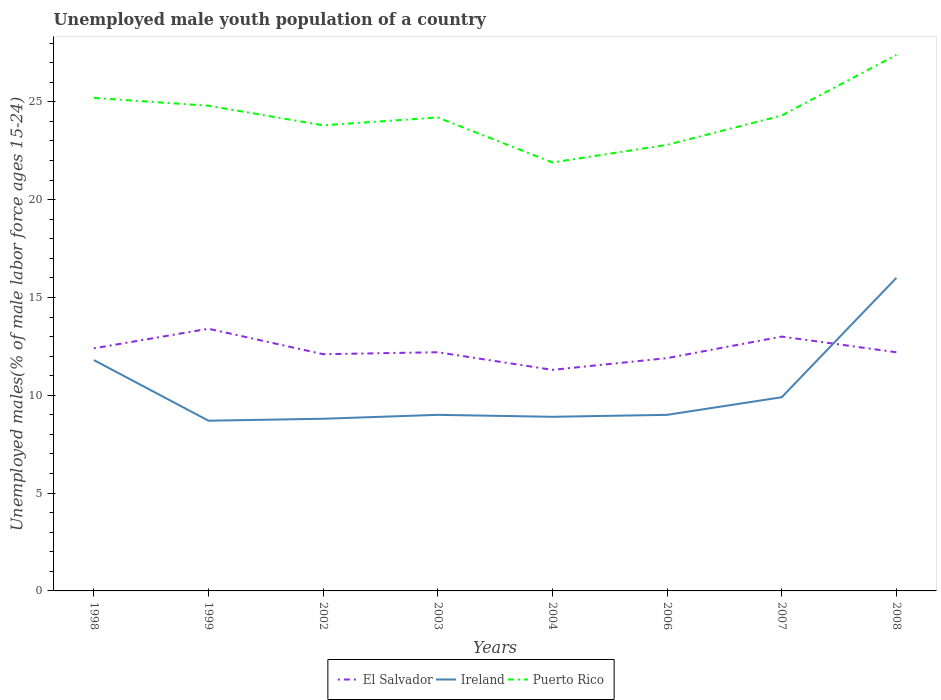How many different coloured lines are there?
Keep it short and to the point. 3. Does the line corresponding to El Salvador intersect with the line corresponding to Ireland?
Provide a succinct answer. Yes. Is the number of lines equal to the number of legend labels?
Ensure brevity in your answer.  Yes. Across all years, what is the maximum percentage of unemployed male youth population in El Salvador?
Provide a succinct answer. 11.3. What is the total percentage of unemployed male youth population in El Salvador in the graph?
Ensure brevity in your answer.  0.8. What is the difference between the highest and the second highest percentage of unemployed male youth population in El Salvador?
Give a very brief answer. 2.1. What is the difference between the highest and the lowest percentage of unemployed male youth population in Puerto Rico?
Your response must be concise. 3. How many years are there in the graph?
Ensure brevity in your answer.  8. Are the values on the major ticks of Y-axis written in scientific E-notation?
Offer a terse response. No. How many legend labels are there?
Offer a terse response. 3. How are the legend labels stacked?
Ensure brevity in your answer.  Horizontal. What is the title of the graph?
Your response must be concise. Unemployed male youth population of a country. What is the label or title of the X-axis?
Keep it short and to the point. Years. What is the label or title of the Y-axis?
Offer a terse response. Unemployed males(% of male labor force ages 15-24). What is the Unemployed males(% of male labor force ages 15-24) in El Salvador in 1998?
Your answer should be compact. 12.4. What is the Unemployed males(% of male labor force ages 15-24) of Ireland in 1998?
Offer a terse response. 11.8. What is the Unemployed males(% of male labor force ages 15-24) in Puerto Rico in 1998?
Offer a very short reply. 25.2. What is the Unemployed males(% of male labor force ages 15-24) in El Salvador in 1999?
Your answer should be compact. 13.4. What is the Unemployed males(% of male labor force ages 15-24) of Ireland in 1999?
Give a very brief answer. 8.7. What is the Unemployed males(% of male labor force ages 15-24) of Puerto Rico in 1999?
Your response must be concise. 24.8. What is the Unemployed males(% of male labor force ages 15-24) of El Salvador in 2002?
Keep it short and to the point. 12.1. What is the Unemployed males(% of male labor force ages 15-24) in Ireland in 2002?
Keep it short and to the point. 8.8. What is the Unemployed males(% of male labor force ages 15-24) in Puerto Rico in 2002?
Your answer should be very brief. 23.8. What is the Unemployed males(% of male labor force ages 15-24) in El Salvador in 2003?
Keep it short and to the point. 12.2. What is the Unemployed males(% of male labor force ages 15-24) in Ireland in 2003?
Keep it short and to the point. 9. What is the Unemployed males(% of male labor force ages 15-24) in Puerto Rico in 2003?
Keep it short and to the point. 24.2. What is the Unemployed males(% of male labor force ages 15-24) in El Salvador in 2004?
Offer a very short reply. 11.3. What is the Unemployed males(% of male labor force ages 15-24) in Ireland in 2004?
Offer a very short reply. 8.9. What is the Unemployed males(% of male labor force ages 15-24) in Puerto Rico in 2004?
Your response must be concise. 21.9. What is the Unemployed males(% of male labor force ages 15-24) of El Salvador in 2006?
Your answer should be compact. 11.9. What is the Unemployed males(% of male labor force ages 15-24) in Ireland in 2006?
Provide a succinct answer. 9. What is the Unemployed males(% of male labor force ages 15-24) in Puerto Rico in 2006?
Your answer should be compact. 22.8. What is the Unemployed males(% of male labor force ages 15-24) in Ireland in 2007?
Offer a very short reply. 9.9. What is the Unemployed males(% of male labor force ages 15-24) in Puerto Rico in 2007?
Your response must be concise. 24.3. What is the Unemployed males(% of male labor force ages 15-24) in El Salvador in 2008?
Keep it short and to the point. 12.2. What is the Unemployed males(% of male labor force ages 15-24) of Ireland in 2008?
Offer a terse response. 16. What is the Unemployed males(% of male labor force ages 15-24) of Puerto Rico in 2008?
Provide a short and direct response. 27.4. Across all years, what is the maximum Unemployed males(% of male labor force ages 15-24) in El Salvador?
Ensure brevity in your answer.  13.4. Across all years, what is the maximum Unemployed males(% of male labor force ages 15-24) of Ireland?
Give a very brief answer. 16. Across all years, what is the maximum Unemployed males(% of male labor force ages 15-24) of Puerto Rico?
Your answer should be compact. 27.4. Across all years, what is the minimum Unemployed males(% of male labor force ages 15-24) of El Salvador?
Offer a terse response. 11.3. Across all years, what is the minimum Unemployed males(% of male labor force ages 15-24) of Ireland?
Your response must be concise. 8.7. Across all years, what is the minimum Unemployed males(% of male labor force ages 15-24) of Puerto Rico?
Provide a short and direct response. 21.9. What is the total Unemployed males(% of male labor force ages 15-24) in El Salvador in the graph?
Keep it short and to the point. 98.5. What is the total Unemployed males(% of male labor force ages 15-24) in Ireland in the graph?
Offer a terse response. 82.1. What is the total Unemployed males(% of male labor force ages 15-24) of Puerto Rico in the graph?
Your answer should be compact. 194.4. What is the difference between the Unemployed males(% of male labor force ages 15-24) in Ireland in 1998 and that in 1999?
Offer a very short reply. 3.1. What is the difference between the Unemployed males(% of male labor force ages 15-24) in El Salvador in 1998 and that in 2002?
Your response must be concise. 0.3. What is the difference between the Unemployed males(% of male labor force ages 15-24) of Ireland in 1998 and that in 2002?
Make the answer very short. 3. What is the difference between the Unemployed males(% of male labor force ages 15-24) of El Salvador in 1998 and that in 2003?
Your answer should be compact. 0.2. What is the difference between the Unemployed males(% of male labor force ages 15-24) of Puerto Rico in 1998 and that in 2003?
Ensure brevity in your answer.  1. What is the difference between the Unemployed males(% of male labor force ages 15-24) in Puerto Rico in 1998 and that in 2006?
Provide a succinct answer. 2.4. What is the difference between the Unemployed males(% of male labor force ages 15-24) of Puerto Rico in 1998 and that in 2007?
Your answer should be very brief. 0.9. What is the difference between the Unemployed males(% of male labor force ages 15-24) in El Salvador in 1998 and that in 2008?
Ensure brevity in your answer.  0.2. What is the difference between the Unemployed males(% of male labor force ages 15-24) of Puerto Rico in 1999 and that in 2002?
Make the answer very short. 1. What is the difference between the Unemployed males(% of male labor force ages 15-24) in Puerto Rico in 1999 and that in 2003?
Make the answer very short. 0.6. What is the difference between the Unemployed males(% of male labor force ages 15-24) of Ireland in 1999 and that in 2004?
Your answer should be compact. -0.2. What is the difference between the Unemployed males(% of male labor force ages 15-24) of Puerto Rico in 1999 and that in 2004?
Ensure brevity in your answer.  2.9. What is the difference between the Unemployed males(% of male labor force ages 15-24) in Puerto Rico in 1999 and that in 2006?
Offer a terse response. 2. What is the difference between the Unemployed males(% of male labor force ages 15-24) of Ireland in 1999 and that in 2007?
Make the answer very short. -1.2. What is the difference between the Unemployed males(% of male labor force ages 15-24) of Puerto Rico in 1999 and that in 2007?
Keep it short and to the point. 0.5. What is the difference between the Unemployed males(% of male labor force ages 15-24) in El Salvador in 1999 and that in 2008?
Make the answer very short. 1.2. What is the difference between the Unemployed males(% of male labor force ages 15-24) of Ireland in 2002 and that in 2003?
Make the answer very short. -0.2. What is the difference between the Unemployed males(% of male labor force ages 15-24) in Puerto Rico in 2002 and that in 2003?
Offer a very short reply. -0.4. What is the difference between the Unemployed males(% of male labor force ages 15-24) of Ireland in 2002 and that in 2004?
Give a very brief answer. -0.1. What is the difference between the Unemployed males(% of male labor force ages 15-24) of El Salvador in 2002 and that in 2006?
Provide a succinct answer. 0.2. What is the difference between the Unemployed males(% of male labor force ages 15-24) in Ireland in 2002 and that in 2006?
Provide a succinct answer. -0.2. What is the difference between the Unemployed males(% of male labor force ages 15-24) in El Salvador in 2002 and that in 2007?
Ensure brevity in your answer.  -0.9. What is the difference between the Unemployed males(% of male labor force ages 15-24) of Puerto Rico in 2002 and that in 2008?
Offer a terse response. -3.6. What is the difference between the Unemployed males(% of male labor force ages 15-24) in El Salvador in 2003 and that in 2004?
Make the answer very short. 0.9. What is the difference between the Unemployed males(% of male labor force ages 15-24) in Ireland in 2003 and that in 2004?
Provide a succinct answer. 0.1. What is the difference between the Unemployed males(% of male labor force ages 15-24) of Puerto Rico in 2003 and that in 2006?
Offer a terse response. 1.4. What is the difference between the Unemployed males(% of male labor force ages 15-24) of Ireland in 2003 and that in 2008?
Your answer should be very brief. -7. What is the difference between the Unemployed males(% of male labor force ages 15-24) of Puerto Rico in 2003 and that in 2008?
Keep it short and to the point. -3.2. What is the difference between the Unemployed males(% of male labor force ages 15-24) in Ireland in 2004 and that in 2006?
Ensure brevity in your answer.  -0.1. What is the difference between the Unemployed males(% of male labor force ages 15-24) of El Salvador in 2004 and that in 2008?
Ensure brevity in your answer.  -0.9. What is the difference between the Unemployed males(% of male labor force ages 15-24) of Ireland in 2004 and that in 2008?
Provide a succinct answer. -7.1. What is the difference between the Unemployed males(% of male labor force ages 15-24) in Puerto Rico in 2004 and that in 2008?
Keep it short and to the point. -5.5. What is the difference between the Unemployed males(% of male labor force ages 15-24) in Ireland in 2006 and that in 2008?
Offer a terse response. -7. What is the difference between the Unemployed males(% of male labor force ages 15-24) in Puerto Rico in 2006 and that in 2008?
Your answer should be very brief. -4.6. What is the difference between the Unemployed males(% of male labor force ages 15-24) in El Salvador in 2007 and that in 2008?
Your response must be concise. 0.8. What is the difference between the Unemployed males(% of male labor force ages 15-24) of Puerto Rico in 2007 and that in 2008?
Your answer should be very brief. -3.1. What is the difference between the Unemployed males(% of male labor force ages 15-24) of El Salvador in 1998 and the Unemployed males(% of male labor force ages 15-24) of Puerto Rico in 1999?
Provide a short and direct response. -12.4. What is the difference between the Unemployed males(% of male labor force ages 15-24) in Ireland in 1998 and the Unemployed males(% of male labor force ages 15-24) in Puerto Rico in 2002?
Make the answer very short. -12. What is the difference between the Unemployed males(% of male labor force ages 15-24) in El Salvador in 1998 and the Unemployed males(% of male labor force ages 15-24) in Ireland in 2003?
Make the answer very short. 3.4. What is the difference between the Unemployed males(% of male labor force ages 15-24) of El Salvador in 1998 and the Unemployed males(% of male labor force ages 15-24) of Puerto Rico in 2003?
Your answer should be very brief. -11.8. What is the difference between the Unemployed males(% of male labor force ages 15-24) of Ireland in 1998 and the Unemployed males(% of male labor force ages 15-24) of Puerto Rico in 2003?
Keep it short and to the point. -12.4. What is the difference between the Unemployed males(% of male labor force ages 15-24) of El Salvador in 1998 and the Unemployed males(% of male labor force ages 15-24) of Ireland in 2006?
Your response must be concise. 3.4. What is the difference between the Unemployed males(% of male labor force ages 15-24) of Ireland in 1998 and the Unemployed males(% of male labor force ages 15-24) of Puerto Rico in 2008?
Provide a short and direct response. -15.6. What is the difference between the Unemployed males(% of male labor force ages 15-24) in El Salvador in 1999 and the Unemployed males(% of male labor force ages 15-24) in Puerto Rico in 2002?
Your response must be concise. -10.4. What is the difference between the Unemployed males(% of male labor force ages 15-24) in Ireland in 1999 and the Unemployed males(% of male labor force ages 15-24) in Puerto Rico in 2002?
Ensure brevity in your answer.  -15.1. What is the difference between the Unemployed males(% of male labor force ages 15-24) in El Salvador in 1999 and the Unemployed males(% of male labor force ages 15-24) in Ireland in 2003?
Your answer should be compact. 4.4. What is the difference between the Unemployed males(% of male labor force ages 15-24) of El Salvador in 1999 and the Unemployed males(% of male labor force ages 15-24) of Puerto Rico in 2003?
Your response must be concise. -10.8. What is the difference between the Unemployed males(% of male labor force ages 15-24) in Ireland in 1999 and the Unemployed males(% of male labor force ages 15-24) in Puerto Rico in 2003?
Offer a very short reply. -15.5. What is the difference between the Unemployed males(% of male labor force ages 15-24) of El Salvador in 1999 and the Unemployed males(% of male labor force ages 15-24) of Puerto Rico in 2004?
Provide a short and direct response. -8.5. What is the difference between the Unemployed males(% of male labor force ages 15-24) in El Salvador in 1999 and the Unemployed males(% of male labor force ages 15-24) in Ireland in 2006?
Ensure brevity in your answer.  4.4. What is the difference between the Unemployed males(% of male labor force ages 15-24) of Ireland in 1999 and the Unemployed males(% of male labor force ages 15-24) of Puerto Rico in 2006?
Provide a succinct answer. -14.1. What is the difference between the Unemployed males(% of male labor force ages 15-24) of Ireland in 1999 and the Unemployed males(% of male labor force ages 15-24) of Puerto Rico in 2007?
Provide a short and direct response. -15.6. What is the difference between the Unemployed males(% of male labor force ages 15-24) in Ireland in 1999 and the Unemployed males(% of male labor force ages 15-24) in Puerto Rico in 2008?
Offer a terse response. -18.7. What is the difference between the Unemployed males(% of male labor force ages 15-24) in El Salvador in 2002 and the Unemployed males(% of male labor force ages 15-24) in Ireland in 2003?
Your response must be concise. 3.1. What is the difference between the Unemployed males(% of male labor force ages 15-24) of Ireland in 2002 and the Unemployed males(% of male labor force ages 15-24) of Puerto Rico in 2003?
Ensure brevity in your answer.  -15.4. What is the difference between the Unemployed males(% of male labor force ages 15-24) of Ireland in 2002 and the Unemployed males(% of male labor force ages 15-24) of Puerto Rico in 2004?
Offer a very short reply. -13.1. What is the difference between the Unemployed males(% of male labor force ages 15-24) of El Salvador in 2002 and the Unemployed males(% of male labor force ages 15-24) of Ireland in 2006?
Make the answer very short. 3.1. What is the difference between the Unemployed males(% of male labor force ages 15-24) of El Salvador in 2002 and the Unemployed males(% of male labor force ages 15-24) of Puerto Rico in 2006?
Your answer should be very brief. -10.7. What is the difference between the Unemployed males(% of male labor force ages 15-24) of Ireland in 2002 and the Unemployed males(% of male labor force ages 15-24) of Puerto Rico in 2007?
Offer a terse response. -15.5. What is the difference between the Unemployed males(% of male labor force ages 15-24) of El Salvador in 2002 and the Unemployed males(% of male labor force ages 15-24) of Ireland in 2008?
Provide a short and direct response. -3.9. What is the difference between the Unemployed males(% of male labor force ages 15-24) of El Salvador in 2002 and the Unemployed males(% of male labor force ages 15-24) of Puerto Rico in 2008?
Offer a terse response. -15.3. What is the difference between the Unemployed males(% of male labor force ages 15-24) of Ireland in 2002 and the Unemployed males(% of male labor force ages 15-24) of Puerto Rico in 2008?
Your answer should be compact. -18.6. What is the difference between the Unemployed males(% of male labor force ages 15-24) in El Salvador in 2003 and the Unemployed males(% of male labor force ages 15-24) in Puerto Rico in 2004?
Your response must be concise. -9.7. What is the difference between the Unemployed males(% of male labor force ages 15-24) of El Salvador in 2003 and the Unemployed males(% of male labor force ages 15-24) of Ireland in 2006?
Provide a short and direct response. 3.2. What is the difference between the Unemployed males(% of male labor force ages 15-24) in Ireland in 2003 and the Unemployed males(% of male labor force ages 15-24) in Puerto Rico in 2006?
Provide a succinct answer. -13.8. What is the difference between the Unemployed males(% of male labor force ages 15-24) of El Salvador in 2003 and the Unemployed males(% of male labor force ages 15-24) of Ireland in 2007?
Ensure brevity in your answer.  2.3. What is the difference between the Unemployed males(% of male labor force ages 15-24) of Ireland in 2003 and the Unemployed males(% of male labor force ages 15-24) of Puerto Rico in 2007?
Your answer should be compact. -15.3. What is the difference between the Unemployed males(% of male labor force ages 15-24) of El Salvador in 2003 and the Unemployed males(% of male labor force ages 15-24) of Ireland in 2008?
Provide a succinct answer. -3.8. What is the difference between the Unemployed males(% of male labor force ages 15-24) of El Salvador in 2003 and the Unemployed males(% of male labor force ages 15-24) of Puerto Rico in 2008?
Your response must be concise. -15.2. What is the difference between the Unemployed males(% of male labor force ages 15-24) of Ireland in 2003 and the Unemployed males(% of male labor force ages 15-24) of Puerto Rico in 2008?
Offer a terse response. -18.4. What is the difference between the Unemployed males(% of male labor force ages 15-24) in El Salvador in 2004 and the Unemployed males(% of male labor force ages 15-24) in Ireland in 2006?
Offer a very short reply. 2.3. What is the difference between the Unemployed males(% of male labor force ages 15-24) of El Salvador in 2004 and the Unemployed males(% of male labor force ages 15-24) of Puerto Rico in 2006?
Your answer should be very brief. -11.5. What is the difference between the Unemployed males(% of male labor force ages 15-24) in Ireland in 2004 and the Unemployed males(% of male labor force ages 15-24) in Puerto Rico in 2006?
Offer a very short reply. -13.9. What is the difference between the Unemployed males(% of male labor force ages 15-24) in Ireland in 2004 and the Unemployed males(% of male labor force ages 15-24) in Puerto Rico in 2007?
Make the answer very short. -15.4. What is the difference between the Unemployed males(% of male labor force ages 15-24) in El Salvador in 2004 and the Unemployed males(% of male labor force ages 15-24) in Ireland in 2008?
Give a very brief answer. -4.7. What is the difference between the Unemployed males(% of male labor force ages 15-24) in El Salvador in 2004 and the Unemployed males(% of male labor force ages 15-24) in Puerto Rico in 2008?
Offer a very short reply. -16.1. What is the difference between the Unemployed males(% of male labor force ages 15-24) in Ireland in 2004 and the Unemployed males(% of male labor force ages 15-24) in Puerto Rico in 2008?
Offer a terse response. -18.5. What is the difference between the Unemployed males(% of male labor force ages 15-24) of El Salvador in 2006 and the Unemployed males(% of male labor force ages 15-24) of Ireland in 2007?
Provide a succinct answer. 2. What is the difference between the Unemployed males(% of male labor force ages 15-24) of El Salvador in 2006 and the Unemployed males(% of male labor force ages 15-24) of Puerto Rico in 2007?
Keep it short and to the point. -12.4. What is the difference between the Unemployed males(% of male labor force ages 15-24) of Ireland in 2006 and the Unemployed males(% of male labor force ages 15-24) of Puerto Rico in 2007?
Give a very brief answer. -15.3. What is the difference between the Unemployed males(% of male labor force ages 15-24) in El Salvador in 2006 and the Unemployed males(% of male labor force ages 15-24) in Ireland in 2008?
Your response must be concise. -4.1. What is the difference between the Unemployed males(% of male labor force ages 15-24) in El Salvador in 2006 and the Unemployed males(% of male labor force ages 15-24) in Puerto Rico in 2008?
Give a very brief answer. -15.5. What is the difference between the Unemployed males(% of male labor force ages 15-24) of Ireland in 2006 and the Unemployed males(% of male labor force ages 15-24) of Puerto Rico in 2008?
Make the answer very short. -18.4. What is the difference between the Unemployed males(% of male labor force ages 15-24) in El Salvador in 2007 and the Unemployed males(% of male labor force ages 15-24) in Puerto Rico in 2008?
Ensure brevity in your answer.  -14.4. What is the difference between the Unemployed males(% of male labor force ages 15-24) in Ireland in 2007 and the Unemployed males(% of male labor force ages 15-24) in Puerto Rico in 2008?
Keep it short and to the point. -17.5. What is the average Unemployed males(% of male labor force ages 15-24) of El Salvador per year?
Provide a short and direct response. 12.31. What is the average Unemployed males(% of male labor force ages 15-24) in Ireland per year?
Offer a very short reply. 10.26. What is the average Unemployed males(% of male labor force ages 15-24) of Puerto Rico per year?
Offer a terse response. 24.3. In the year 1998, what is the difference between the Unemployed males(% of male labor force ages 15-24) of El Salvador and Unemployed males(% of male labor force ages 15-24) of Ireland?
Offer a very short reply. 0.6. In the year 1998, what is the difference between the Unemployed males(% of male labor force ages 15-24) of El Salvador and Unemployed males(% of male labor force ages 15-24) of Puerto Rico?
Provide a short and direct response. -12.8. In the year 1998, what is the difference between the Unemployed males(% of male labor force ages 15-24) in Ireland and Unemployed males(% of male labor force ages 15-24) in Puerto Rico?
Provide a short and direct response. -13.4. In the year 1999, what is the difference between the Unemployed males(% of male labor force ages 15-24) of El Salvador and Unemployed males(% of male labor force ages 15-24) of Ireland?
Provide a short and direct response. 4.7. In the year 1999, what is the difference between the Unemployed males(% of male labor force ages 15-24) in Ireland and Unemployed males(% of male labor force ages 15-24) in Puerto Rico?
Make the answer very short. -16.1. In the year 2002, what is the difference between the Unemployed males(% of male labor force ages 15-24) in El Salvador and Unemployed males(% of male labor force ages 15-24) in Ireland?
Ensure brevity in your answer.  3.3. In the year 2003, what is the difference between the Unemployed males(% of male labor force ages 15-24) of Ireland and Unemployed males(% of male labor force ages 15-24) of Puerto Rico?
Make the answer very short. -15.2. In the year 2004, what is the difference between the Unemployed males(% of male labor force ages 15-24) of El Salvador and Unemployed males(% of male labor force ages 15-24) of Ireland?
Offer a very short reply. 2.4. In the year 2004, what is the difference between the Unemployed males(% of male labor force ages 15-24) in Ireland and Unemployed males(% of male labor force ages 15-24) in Puerto Rico?
Offer a very short reply. -13. In the year 2006, what is the difference between the Unemployed males(% of male labor force ages 15-24) of El Salvador and Unemployed males(% of male labor force ages 15-24) of Puerto Rico?
Provide a short and direct response. -10.9. In the year 2006, what is the difference between the Unemployed males(% of male labor force ages 15-24) in Ireland and Unemployed males(% of male labor force ages 15-24) in Puerto Rico?
Keep it short and to the point. -13.8. In the year 2007, what is the difference between the Unemployed males(% of male labor force ages 15-24) of Ireland and Unemployed males(% of male labor force ages 15-24) of Puerto Rico?
Ensure brevity in your answer.  -14.4. In the year 2008, what is the difference between the Unemployed males(% of male labor force ages 15-24) of El Salvador and Unemployed males(% of male labor force ages 15-24) of Ireland?
Your response must be concise. -3.8. In the year 2008, what is the difference between the Unemployed males(% of male labor force ages 15-24) in El Salvador and Unemployed males(% of male labor force ages 15-24) in Puerto Rico?
Your response must be concise. -15.2. What is the ratio of the Unemployed males(% of male labor force ages 15-24) of El Salvador in 1998 to that in 1999?
Give a very brief answer. 0.93. What is the ratio of the Unemployed males(% of male labor force ages 15-24) in Ireland in 1998 to that in 1999?
Make the answer very short. 1.36. What is the ratio of the Unemployed males(% of male labor force ages 15-24) of Puerto Rico in 1998 to that in 1999?
Ensure brevity in your answer.  1.02. What is the ratio of the Unemployed males(% of male labor force ages 15-24) of El Salvador in 1998 to that in 2002?
Keep it short and to the point. 1.02. What is the ratio of the Unemployed males(% of male labor force ages 15-24) of Ireland in 1998 to that in 2002?
Keep it short and to the point. 1.34. What is the ratio of the Unemployed males(% of male labor force ages 15-24) of Puerto Rico in 1998 to that in 2002?
Offer a terse response. 1.06. What is the ratio of the Unemployed males(% of male labor force ages 15-24) of El Salvador in 1998 to that in 2003?
Your response must be concise. 1.02. What is the ratio of the Unemployed males(% of male labor force ages 15-24) in Ireland in 1998 to that in 2003?
Keep it short and to the point. 1.31. What is the ratio of the Unemployed males(% of male labor force ages 15-24) of Puerto Rico in 1998 to that in 2003?
Provide a short and direct response. 1.04. What is the ratio of the Unemployed males(% of male labor force ages 15-24) of El Salvador in 1998 to that in 2004?
Make the answer very short. 1.1. What is the ratio of the Unemployed males(% of male labor force ages 15-24) in Ireland in 1998 to that in 2004?
Offer a very short reply. 1.33. What is the ratio of the Unemployed males(% of male labor force ages 15-24) in Puerto Rico in 1998 to that in 2004?
Provide a short and direct response. 1.15. What is the ratio of the Unemployed males(% of male labor force ages 15-24) of El Salvador in 1998 to that in 2006?
Your response must be concise. 1.04. What is the ratio of the Unemployed males(% of male labor force ages 15-24) in Ireland in 1998 to that in 2006?
Provide a succinct answer. 1.31. What is the ratio of the Unemployed males(% of male labor force ages 15-24) in Puerto Rico in 1998 to that in 2006?
Make the answer very short. 1.11. What is the ratio of the Unemployed males(% of male labor force ages 15-24) in El Salvador in 1998 to that in 2007?
Your answer should be very brief. 0.95. What is the ratio of the Unemployed males(% of male labor force ages 15-24) of Ireland in 1998 to that in 2007?
Your answer should be compact. 1.19. What is the ratio of the Unemployed males(% of male labor force ages 15-24) of Puerto Rico in 1998 to that in 2007?
Give a very brief answer. 1.04. What is the ratio of the Unemployed males(% of male labor force ages 15-24) in El Salvador in 1998 to that in 2008?
Ensure brevity in your answer.  1.02. What is the ratio of the Unemployed males(% of male labor force ages 15-24) in Ireland in 1998 to that in 2008?
Give a very brief answer. 0.74. What is the ratio of the Unemployed males(% of male labor force ages 15-24) of Puerto Rico in 1998 to that in 2008?
Give a very brief answer. 0.92. What is the ratio of the Unemployed males(% of male labor force ages 15-24) of El Salvador in 1999 to that in 2002?
Offer a very short reply. 1.11. What is the ratio of the Unemployed males(% of male labor force ages 15-24) of Ireland in 1999 to that in 2002?
Give a very brief answer. 0.99. What is the ratio of the Unemployed males(% of male labor force ages 15-24) in Puerto Rico in 1999 to that in 2002?
Offer a very short reply. 1.04. What is the ratio of the Unemployed males(% of male labor force ages 15-24) in El Salvador in 1999 to that in 2003?
Your answer should be compact. 1.1. What is the ratio of the Unemployed males(% of male labor force ages 15-24) of Ireland in 1999 to that in 2003?
Provide a short and direct response. 0.97. What is the ratio of the Unemployed males(% of male labor force ages 15-24) in Puerto Rico in 1999 to that in 2003?
Make the answer very short. 1.02. What is the ratio of the Unemployed males(% of male labor force ages 15-24) of El Salvador in 1999 to that in 2004?
Offer a very short reply. 1.19. What is the ratio of the Unemployed males(% of male labor force ages 15-24) of Ireland in 1999 to that in 2004?
Your answer should be very brief. 0.98. What is the ratio of the Unemployed males(% of male labor force ages 15-24) of Puerto Rico in 1999 to that in 2004?
Your response must be concise. 1.13. What is the ratio of the Unemployed males(% of male labor force ages 15-24) in El Salvador in 1999 to that in 2006?
Give a very brief answer. 1.13. What is the ratio of the Unemployed males(% of male labor force ages 15-24) in Ireland in 1999 to that in 2006?
Your answer should be very brief. 0.97. What is the ratio of the Unemployed males(% of male labor force ages 15-24) in Puerto Rico in 1999 to that in 2006?
Your answer should be compact. 1.09. What is the ratio of the Unemployed males(% of male labor force ages 15-24) in El Salvador in 1999 to that in 2007?
Your response must be concise. 1.03. What is the ratio of the Unemployed males(% of male labor force ages 15-24) in Ireland in 1999 to that in 2007?
Provide a short and direct response. 0.88. What is the ratio of the Unemployed males(% of male labor force ages 15-24) of Puerto Rico in 1999 to that in 2007?
Ensure brevity in your answer.  1.02. What is the ratio of the Unemployed males(% of male labor force ages 15-24) in El Salvador in 1999 to that in 2008?
Your answer should be very brief. 1.1. What is the ratio of the Unemployed males(% of male labor force ages 15-24) in Ireland in 1999 to that in 2008?
Your answer should be very brief. 0.54. What is the ratio of the Unemployed males(% of male labor force ages 15-24) of Puerto Rico in 1999 to that in 2008?
Keep it short and to the point. 0.91. What is the ratio of the Unemployed males(% of male labor force ages 15-24) of Ireland in 2002 to that in 2003?
Provide a short and direct response. 0.98. What is the ratio of the Unemployed males(% of male labor force ages 15-24) of Puerto Rico in 2002 to that in 2003?
Make the answer very short. 0.98. What is the ratio of the Unemployed males(% of male labor force ages 15-24) in El Salvador in 2002 to that in 2004?
Your answer should be compact. 1.07. What is the ratio of the Unemployed males(% of male labor force ages 15-24) of Ireland in 2002 to that in 2004?
Make the answer very short. 0.99. What is the ratio of the Unemployed males(% of male labor force ages 15-24) of Puerto Rico in 2002 to that in 2004?
Ensure brevity in your answer.  1.09. What is the ratio of the Unemployed males(% of male labor force ages 15-24) in El Salvador in 2002 to that in 2006?
Offer a terse response. 1.02. What is the ratio of the Unemployed males(% of male labor force ages 15-24) of Ireland in 2002 to that in 2006?
Provide a short and direct response. 0.98. What is the ratio of the Unemployed males(% of male labor force ages 15-24) of Puerto Rico in 2002 to that in 2006?
Offer a terse response. 1.04. What is the ratio of the Unemployed males(% of male labor force ages 15-24) in El Salvador in 2002 to that in 2007?
Provide a succinct answer. 0.93. What is the ratio of the Unemployed males(% of male labor force ages 15-24) of Ireland in 2002 to that in 2007?
Your answer should be very brief. 0.89. What is the ratio of the Unemployed males(% of male labor force ages 15-24) of Puerto Rico in 2002 to that in 2007?
Provide a succinct answer. 0.98. What is the ratio of the Unemployed males(% of male labor force ages 15-24) in Ireland in 2002 to that in 2008?
Offer a terse response. 0.55. What is the ratio of the Unemployed males(% of male labor force ages 15-24) in Puerto Rico in 2002 to that in 2008?
Your response must be concise. 0.87. What is the ratio of the Unemployed males(% of male labor force ages 15-24) of El Salvador in 2003 to that in 2004?
Provide a short and direct response. 1.08. What is the ratio of the Unemployed males(% of male labor force ages 15-24) of Ireland in 2003 to that in 2004?
Offer a terse response. 1.01. What is the ratio of the Unemployed males(% of male labor force ages 15-24) in Puerto Rico in 2003 to that in 2004?
Ensure brevity in your answer.  1.1. What is the ratio of the Unemployed males(% of male labor force ages 15-24) of El Salvador in 2003 to that in 2006?
Your response must be concise. 1.03. What is the ratio of the Unemployed males(% of male labor force ages 15-24) of Puerto Rico in 2003 to that in 2006?
Provide a short and direct response. 1.06. What is the ratio of the Unemployed males(% of male labor force ages 15-24) of El Salvador in 2003 to that in 2007?
Give a very brief answer. 0.94. What is the ratio of the Unemployed males(% of male labor force ages 15-24) of Ireland in 2003 to that in 2007?
Give a very brief answer. 0.91. What is the ratio of the Unemployed males(% of male labor force ages 15-24) in Puerto Rico in 2003 to that in 2007?
Keep it short and to the point. 1. What is the ratio of the Unemployed males(% of male labor force ages 15-24) of El Salvador in 2003 to that in 2008?
Provide a succinct answer. 1. What is the ratio of the Unemployed males(% of male labor force ages 15-24) in Ireland in 2003 to that in 2008?
Offer a terse response. 0.56. What is the ratio of the Unemployed males(% of male labor force ages 15-24) in Puerto Rico in 2003 to that in 2008?
Give a very brief answer. 0.88. What is the ratio of the Unemployed males(% of male labor force ages 15-24) of El Salvador in 2004 to that in 2006?
Give a very brief answer. 0.95. What is the ratio of the Unemployed males(% of male labor force ages 15-24) in Ireland in 2004 to that in 2006?
Offer a very short reply. 0.99. What is the ratio of the Unemployed males(% of male labor force ages 15-24) of Puerto Rico in 2004 to that in 2006?
Provide a short and direct response. 0.96. What is the ratio of the Unemployed males(% of male labor force ages 15-24) in El Salvador in 2004 to that in 2007?
Offer a very short reply. 0.87. What is the ratio of the Unemployed males(% of male labor force ages 15-24) of Ireland in 2004 to that in 2007?
Your answer should be compact. 0.9. What is the ratio of the Unemployed males(% of male labor force ages 15-24) in Puerto Rico in 2004 to that in 2007?
Ensure brevity in your answer.  0.9. What is the ratio of the Unemployed males(% of male labor force ages 15-24) of El Salvador in 2004 to that in 2008?
Your answer should be very brief. 0.93. What is the ratio of the Unemployed males(% of male labor force ages 15-24) of Ireland in 2004 to that in 2008?
Offer a very short reply. 0.56. What is the ratio of the Unemployed males(% of male labor force ages 15-24) in Puerto Rico in 2004 to that in 2008?
Provide a short and direct response. 0.8. What is the ratio of the Unemployed males(% of male labor force ages 15-24) in El Salvador in 2006 to that in 2007?
Ensure brevity in your answer.  0.92. What is the ratio of the Unemployed males(% of male labor force ages 15-24) of Puerto Rico in 2006 to that in 2007?
Offer a very short reply. 0.94. What is the ratio of the Unemployed males(% of male labor force ages 15-24) in El Salvador in 2006 to that in 2008?
Offer a terse response. 0.98. What is the ratio of the Unemployed males(% of male labor force ages 15-24) of Ireland in 2006 to that in 2008?
Make the answer very short. 0.56. What is the ratio of the Unemployed males(% of male labor force ages 15-24) in Puerto Rico in 2006 to that in 2008?
Ensure brevity in your answer.  0.83. What is the ratio of the Unemployed males(% of male labor force ages 15-24) in El Salvador in 2007 to that in 2008?
Your answer should be compact. 1.07. What is the ratio of the Unemployed males(% of male labor force ages 15-24) in Ireland in 2007 to that in 2008?
Provide a succinct answer. 0.62. What is the ratio of the Unemployed males(% of male labor force ages 15-24) in Puerto Rico in 2007 to that in 2008?
Offer a very short reply. 0.89. What is the difference between the highest and the second highest Unemployed males(% of male labor force ages 15-24) in El Salvador?
Give a very brief answer. 0.4. What is the difference between the highest and the lowest Unemployed males(% of male labor force ages 15-24) of El Salvador?
Your answer should be very brief. 2.1. What is the difference between the highest and the lowest Unemployed males(% of male labor force ages 15-24) of Ireland?
Ensure brevity in your answer.  7.3. What is the difference between the highest and the lowest Unemployed males(% of male labor force ages 15-24) of Puerto Rico?
Give a very brief answer. 5.5. 